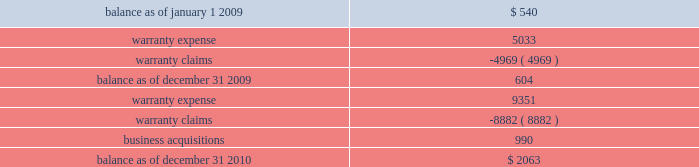On either a straight-line or accelerated basis .
Amortization expense for intangibles was approximately $ 4.2 million , $ 4.1 million and $ 4.1 million during the years ended december 31 , 2010 , 2009 and 2008 , respectively .
Estimated annual amortization expense of the december 31 , 2010 balance for the years ended december 31 , 2011 through 2015 is approximately $ 4.8 million .
Impairment of long-lived assets long-lived assets are reviewed for possible impairment whenever events or circumstances indicate that the carrying amount of such assets may not be recoverable .
If such review indicates that the carrying amount of long- lived assets is not recoverable , the carrying amount of such assets is reduced to fair value .
During the year ended december 31 , 2010 , we recognized impairment charges on certain long-lived assets during the normal course of business of $ 1.3 million .
There were no adjustments to the carrying value of long-lived assets of continuing operations during the years ended december 31 , 2009 or 2008 .
Fair value of financial instruments our debt is reflected on the balance sheet at cost .
Based on market conditions as of december 31 , 2010 , the fair value of our term loans ( see note 5 , 201clong-term obligations 201d ) reasonably approximated the carrying value of $ 590 million .
At december 31 , 2009 , the fair value of our term loans at $ 570 million was below the carrying value of $ 596 million because our interest rate margins were below the rate available in the market .
We estimated the fair value of our term loans by calculating the upfront cash payment a market participant would require to assume our obligations .
The upfront cash payment , excluding any issuance costs , is the amount that a market participant would be able to lend at december 31 , 2010 and 2009 to an entity with a credit rating similar to ours and achieve sufficient cash inflows to cover the scheduled cash outflows under our term loans .
The carrying amounts of our cash and equivalents , net trade receivables and accounts payable approximate fair value .
We apply the market and income approaches to value our financial assets and liabilities , which include the cash surrender value of life insurance , deferred compensation liabilities and interest rate swaps .
Required fair value disclosures are included in note 7 , 201cfair value measurements . 201d product warranties some of our salvage mechanical products are sold with a standard six-month warranty against defects .
Additionally , some of our remanufactured engines are sold with a standard three-year warranty against defects .
We record the estimated warranty costs at the time of sale using historical warranty claim information to project future warranty claims activity and related expenses .
The changes in the warranty reserve are as follows ( in thousands ) : .
Self-insurance reserves we self-insure a portion of employee medical benefits under the terms of our employee health insurance program .
We purchase certain stop-loss insurance to limit our liability exposure .
We also self-insure a portion of .
What was the change in warranty reserve between 2009 and 2010? 
Computations: (2063 - 604)
Answer: 1459.0. 